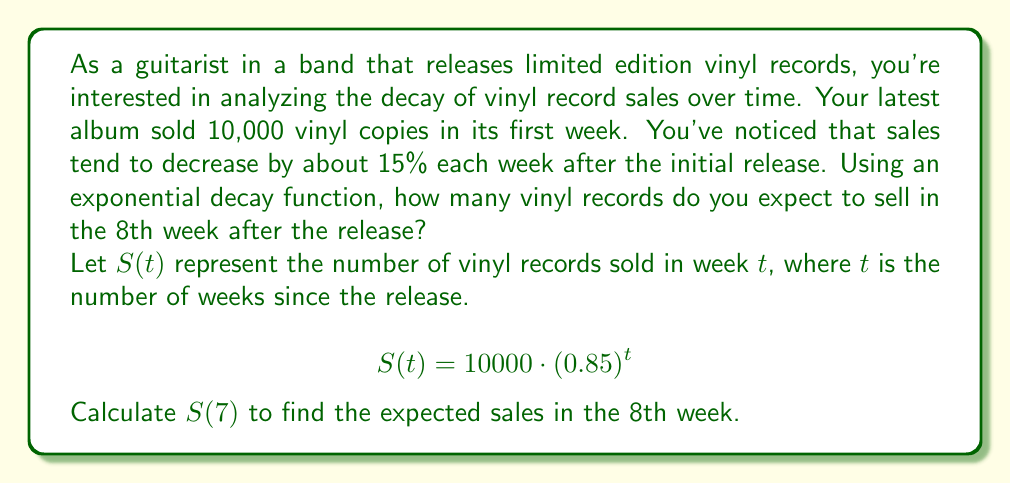What is the answer to this math problem? To solve this problem, we'll use the exponential decay function given:

$$S(t) = 10000 \cdot (0.85)^t$$

Where:
- $S(t)$ is the number of vinyl records sold in week $t$
- 10000 is the initial number of records sold in the first week
- 0.85 represents the decay factor (1 - 0.15, as sales decrease by 15% each week)
- $t$ is the number of weeks since the release

We want to find the sales in the 8th week, which corresponds to $t = 7$ (since we start counting at week 0).

Let's calculate $S(7)$:

$$\begin{align}
S(7) &= 10000 \cdot (0.85)^7 \\
&= 10000 \cdot 0.3759702824 \\
&= 3759.702824
\end{align}$$

Rounding to the nearest whole number (since we can't sell partial records), we get 3760 vinyl records.
Answer: 3760 vinyl records 